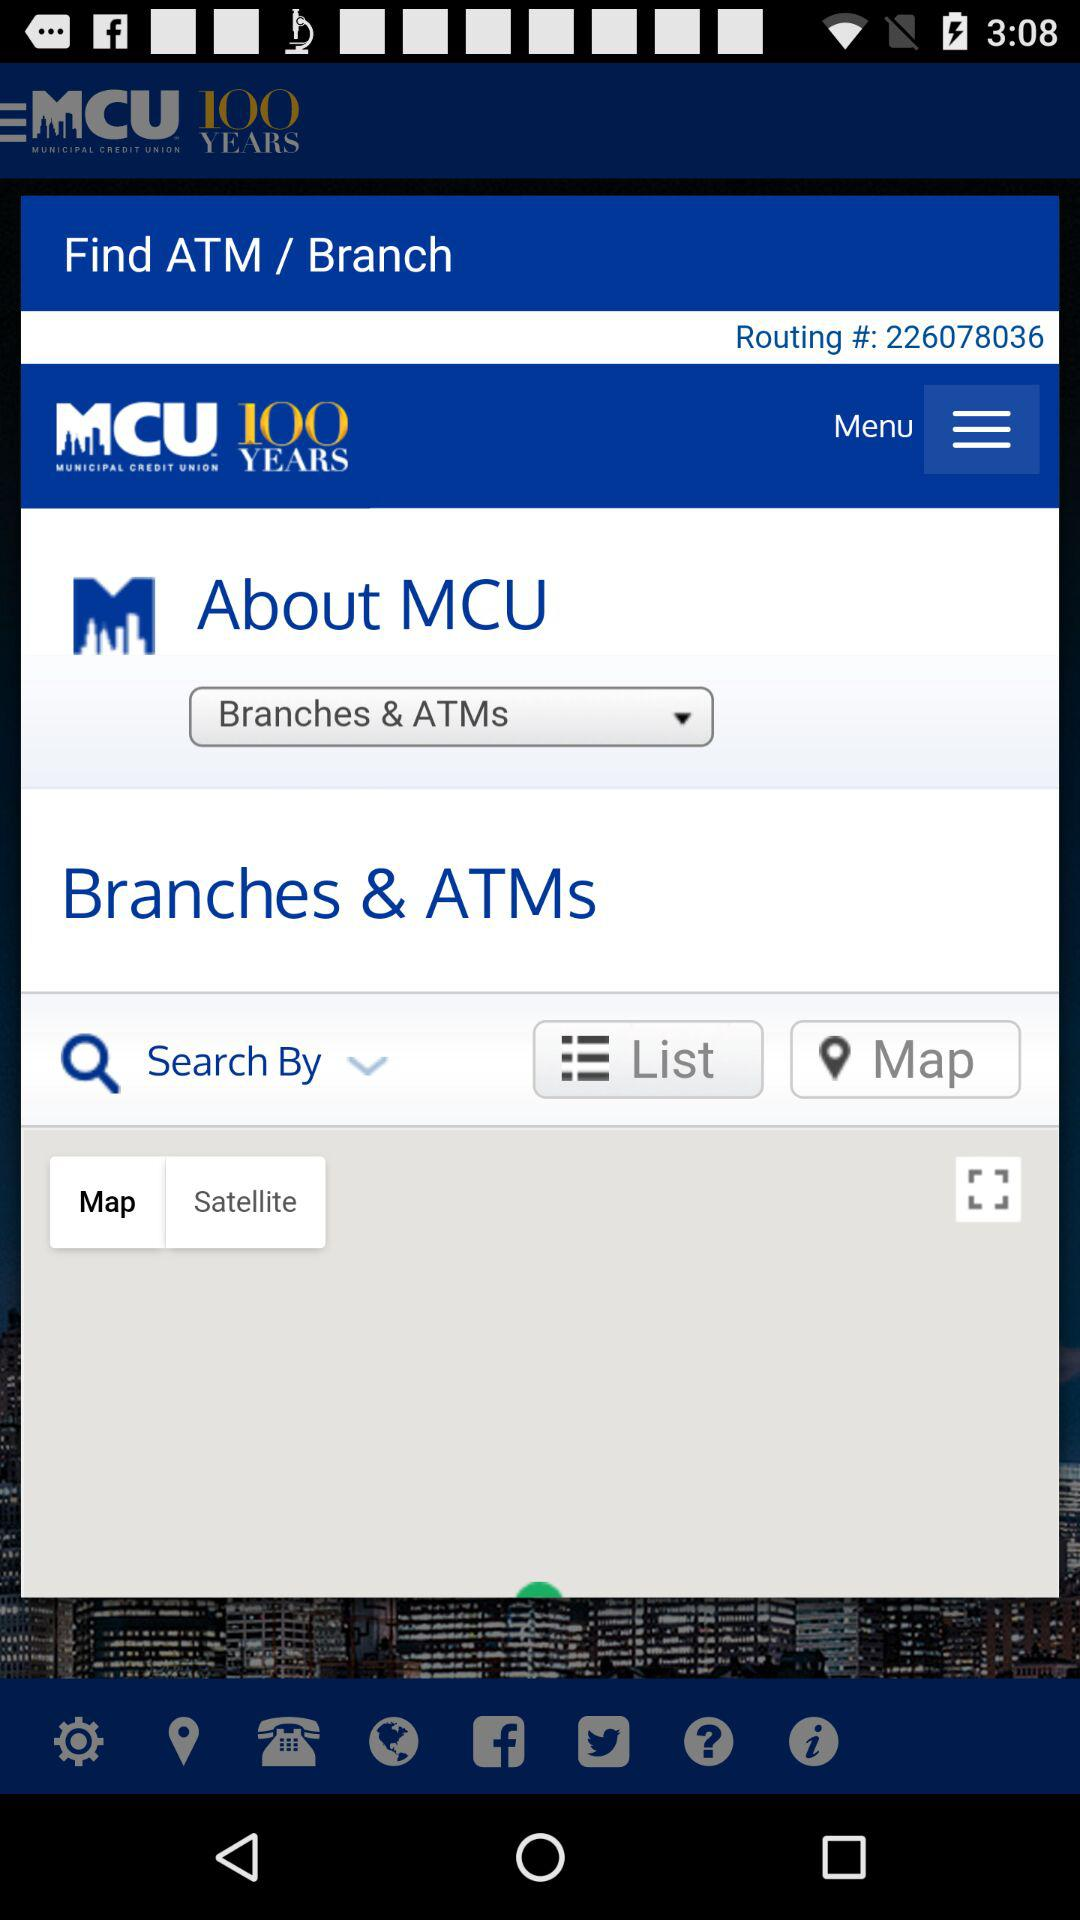What is the app's name? The app's name is "MCU". 